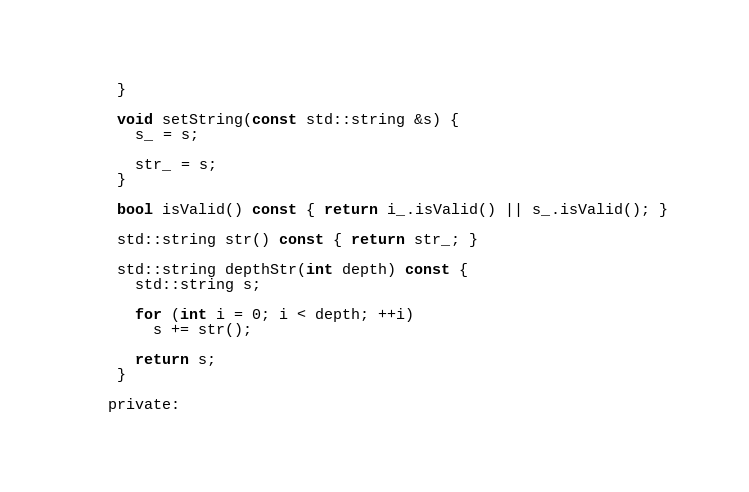Convert code to text. <code><loc_0><loc_0><loc_500><loc_500><_C_>    }

    void setString(const std::string &s) {
      s_ = s;

      str_ = s;
    }

    bool isValid() const { return i_.isValid() || s_.isValid(); }

    std::string str() const { return str_; }

    std::string depthStr(int depth) const {
      std::string s;

      for (int i = 0; i < depth; ++i)
        s += str();

      return s;
    }

   private:</code> 